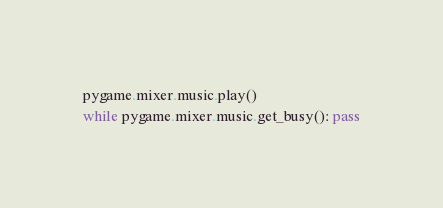<code> <loc_0><loc_0><loc_500><loc_500><_Python_>pygame.mixer.music.play()
while pygame.mixer.music.get_busy(): pass
</code> 